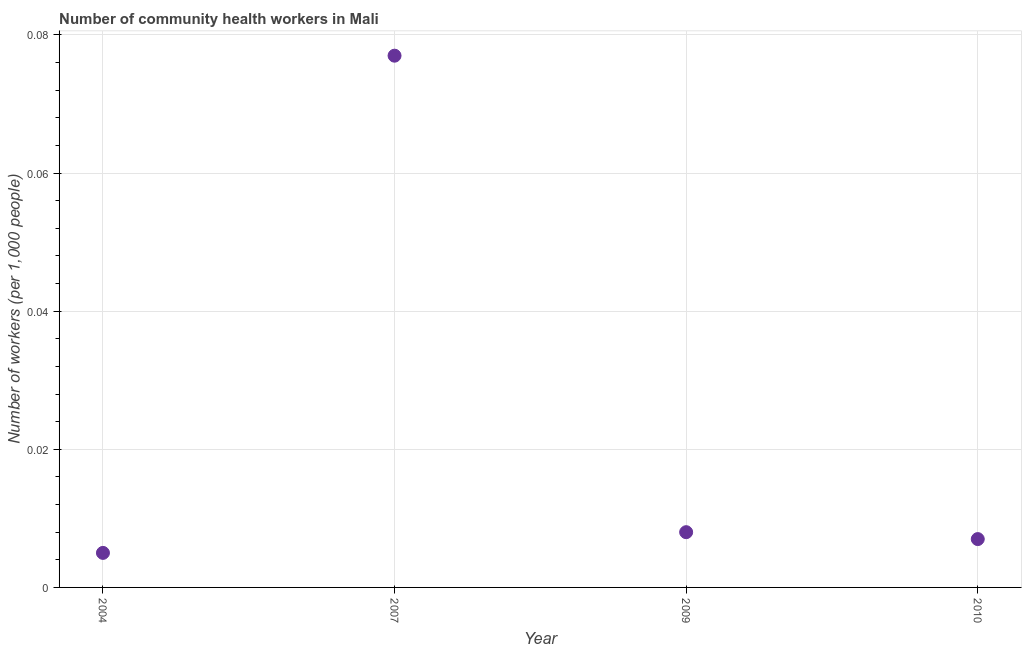What is the number of community health workers in 2007?
Give a very brief answer. 0.08. Across all years, what is the maximum number of community health workers?
Make the answer very short. 0.08. Across all years, what is the minimum number of community health workers?
Your answer should be compact. 0.01. In which year was the number of community health workers maximum?
Offer a very short reply. 2007. What is the sum of the number of community health workers?
Your answer should be very brief. 0.1. What is the difference between the number of community health workers in 2004 and 2007?
Give a very brief answer. -0.07. What is the average number of community health workers per year?
Ensure brevity in your answer.  0.02. What is the median number of community health workers?
Your response must be concise. 0.01. In how many years, is the number of community health workers greater than 0.028 ?
Your response must be concise. 1. What is the ratio of the number of community health workers in 2004 to that in 2010?
Provide a succinct answer. 0.71. Is the number of community health workers in 2004 less than that in 2007?
Provide a succinct answer. Yes. Is the difference between the number of community health workers in 2004 and 2009 greater than the difference between any two years?
Provide a succinct answer. No. What is the difference between the highest and the second highest number of community health workers?
Your answer should be compact. 0.07. Is the sum of the number of community health workers in 2007 and 2010 greater than the maximum number of community health workers across all years?
Your response must be concise. Yes. What is the difference between the highest and the lowest number of community health workers?
Provide a succinct answer. 0.07. Does the number of community health workers monotonically increase over the years?
Your answer should be compact. No. How many dotlines are there?
Offer a very short reply. 1. Are the values on the major ticks of Y-axis written in scientific E-notation?
Keep it short and to the point. No. Does the graph contain any zero values?
Offer a terse response. No. What is the title of the graph?
Your answer should be compact. Number of community health workers in Mali. What is the label or title of the Y-axis?
Your answer should be compact. Number of workers (per 1,0 people). What is the Number of workers (per 1,000 people) in 2004?
Your answer should be compact. 0.01. What is the Number of workers (per 1,000 people) in 2007?
Your response must be concise. 0.08. What is the Number of workers (per 1,000 people) in 2009?
Provide a short and direct response. 0.01. What is the Number of workers (per 1,000 people) in 2010?
Your response must be concise. 0.01. What is the difference between the Number of workers (per 1,000 people) in 2004 and 2007?
Your answer should be compact. -0.07. What is the difference between the Number of workers (per 1,000 people) in 2004 and 2009?
Provide a short and direct response. -0. What is the difference between the Number of workers (per 1,000 people) in 2004 and 2010?
Offer a terse response. -0. What is the difference between the Number of workers (per 1,000 people) in 2007 and 2009?
Keep it short and to the point. 0.07. What is the difference between the Number of workers (per 1,000 people) in 2007 and 2010?
Provide a succinct answer. 0.07. What is the difference between the Number of workers (per 1,000 people) in 2009 and 2010?
Keep it short and to the point. 0. What is the ratio of the Number of workers (per 1,000 people) in 2004 to that in 2007?
Keep it short and to the point. 0.07. What is the ratio of the Number of workers (per 1,000 people) in 2004 to that in 2010?
Your answer should be compact. 0.71. What is the ratio of the Number of workers (per 1,000 people) in 2007 to that in 2009?
Provide a succinct answer. 9.62. What is the ratio of the Number of workers (per 1,000 people) in 2009 to that in 2010?
Your response must be concise. 1.14. 